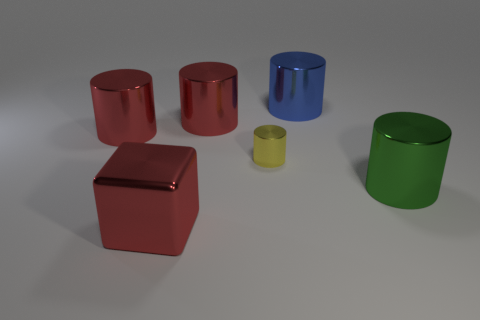Is there any other thing that has the same size as the yellow object?
Your answer should be very brief. No. Is there a yellow shiny thing of the same shape as the green metallic thing?
Your response must be concise. Yes. There is a red shiny thing that is in front of the big green metal cylinder; does it have the same size as the blue metal cylinder right of the tiny metallic object?
Your response must be concise. Yes. Is the number of large shiny blocks greater than the number of big red rubber cubes?
Ensure brevity in your answer.  Yes. How many big red cylinders are made of the same material as the small yellow cylinder?
Your response must be concise. 2. Does the small thing have the same shape as the green object?
Provide a succinct answer. Yes. There is a red metal cylinder to the right of the big red shiny object that is in front of the big metal cylinder on the left side of the shiny cube; what size is it?
Provide a succinct answer. Large. There is a cylinder in front of the yellow metal object; is there a tiny cylinder that is on the right side of it?
Offer a terse response. No. There is a red shiny thing in front of the small thing that is in front of the big blue thing; what number of large metallic cylinders are to the left of it?
Offer a terse response. 1. What color is the large cylinder that is both left of the tiny yellow shiny thing and to the right of the big red block?
Keep it short and to the point. Red. 